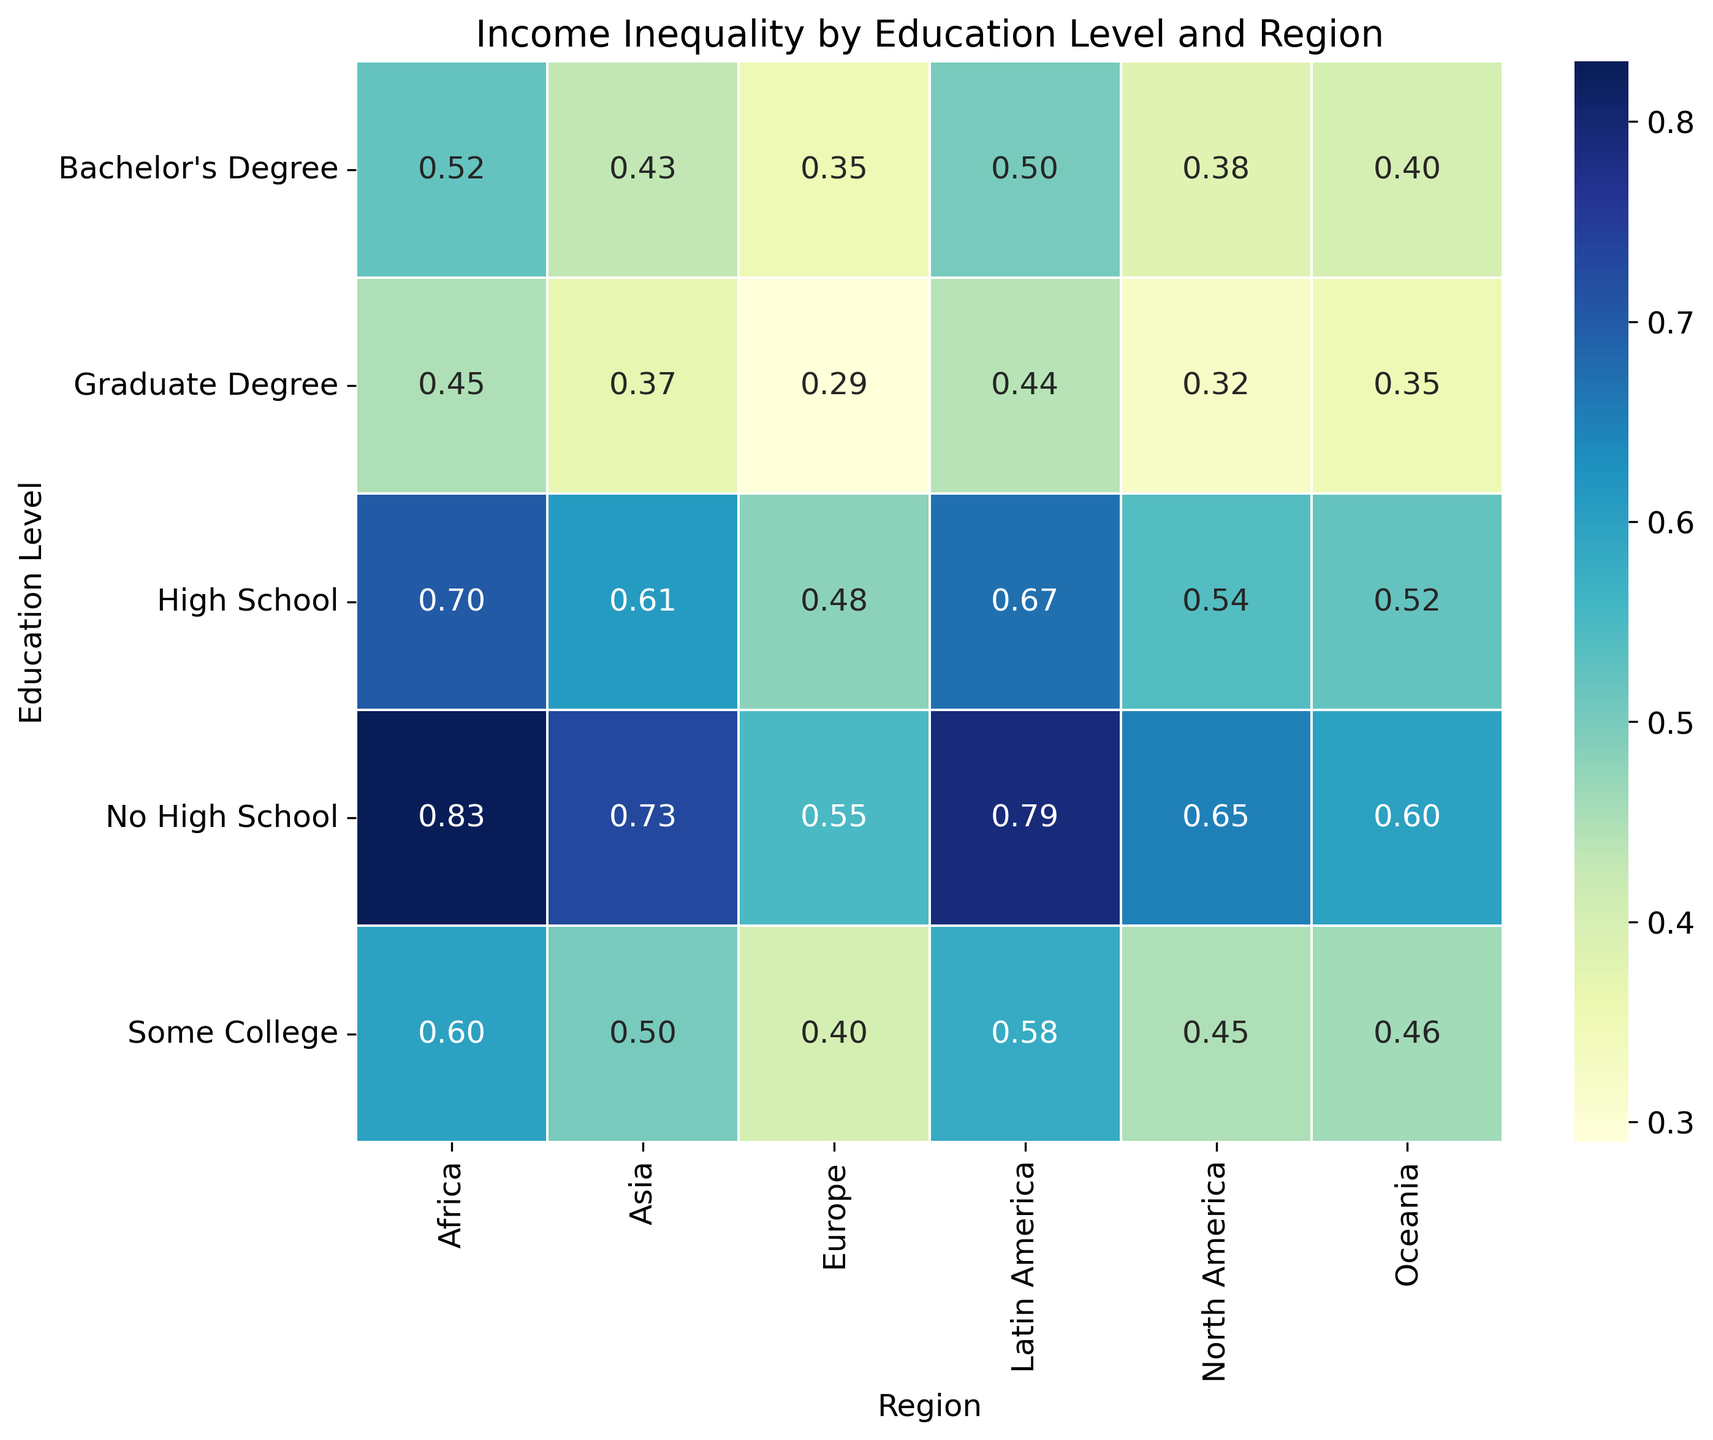What region has the lowest income inequality for individuals with a Bachelor's Degree? The figure has a heatmap showing Income Inequality Index for various regions and education levels. Look at the column for Bachelor's Degree and identify the lowest value.
Answer: Europe How much higher is the income inequality for Africa compared to North America for individuals with no high school education? Find the Income Inequality Index for Africa and North America in the "No High School" row. Subtract the North America value from the Africa value: 0.83 - 0.65 = 0.18.
Answer: 0.18 Which region shows the largest decrease in income inequality from "No High School" to "Graduate Degree"? Calculate the difference in Income Inequality Index between "No High School" and "Graduate Degree" for each region. The largest decrease is the region with the highest difference: Africa (0.83 - 0.45 = 0.38).
Answer: Africa On average, which education level shows the lowest income inequality index across all regions? Calculate the average Income Inequality Index for each education level across all regions and identify the lowest average: 
- No High School: (0.65 + 0.55 + 0.73 + 0.79 + 0.83 + 0.60) / 6 = 0.69
- High School: (0.54 + 0.48 + 0.61 + 0.67 + 0.70 + 0.52) / 6 = 0.58
- Some College: (0.45 + 0.40 + 0.50 + 0.58 + 0.60 + 0.46) / 6 = 0.50
- Bachelor's Degree: (0.38 + 0.35 + 0.43 + 0.50 + 0.52 + 0.40) / 6 = 0.43
- Graduate Degree: (0.32 + 0.29 + 0.37 + 0.44 + 0.45 + 0.35) / 6 = 0.37
The lowest average is for Graduate Degree.
Answer: Graduate Degree Which region has the most consistent income inequality across all education levels? The most consistent region will have the smallest range (difference between the highest and lowest values). Calculate for each region:
- North America: 0.65 - 0.32 = 0.33
- Europe: 0.55 - 0.29 = 0.26
- Asia: 0.73 - 0.37 = 0.36
- Latin America: 0.79 - 0.44 = 0.35
- Africa: 0.83 - 0.45 = 0.38
- Oceania: 0.60 - 0.35 = 0.25
Oceania has the smallest range (0.25).
Answer: Oceania Is there any region where income inequality is the same for individuals with "High School" and "Some College" education? Look for any instances where the values for "High School" and "Some College" are equal in any region: No such instances can be seen.
Answer: No Which region shows the highest income inequality for individuals with a "High School" education? Identify the highest value in the "High School" row: Africa (0.70).
Answer: Africa What is the overall pattern of income inequality as education level increases across all regions? Generally, the Income Inequality Index decreases as the education level increases in all regions. For specific observations, in each region the highest income inequality is at "No High School" and the lowest is at "Graduate Degree".
Answer: Decreases How much lower is the income inequality for Europe with a "Graduate Degree" compared to Oceania with "No High School"? Subtract the Income Inequality Index for Europe with "Graduate Degree" from that of Oceania with "No High School": 0.60 - 0.29 = 0.31.
Answer: 0.31 